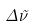<formula> <loc_0><loc_0><loc_500><loc_500>\Delta { \tilde { \nu } }</formula> 